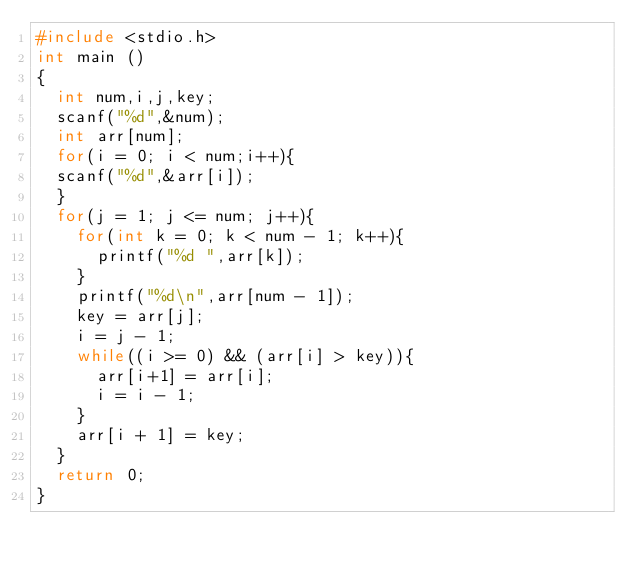Convert code to text. <code><loc_0><loc_0><loc_500><loc_500><_C_>#include <stdio.h>
int main ()
{
  int num,i,j,key;
  scanf("%d",&num);
  int arr[num];
  for(i = 0; i < num;i++){
  scanf("%d",&arr[i]);
  }
  for(j = 1; j <= num; j++){
    for(int k = 0; k < num - 1; k++){
      printf("%d ",arr[k]);
    }
    printf("%d\n",arr[num - 1]);
    key = arr[j];
    i = j - 1;
    while((i >= 0) && (arr[i] > key)){
      arr[i+1] = arr[i];
      i = i - 1;
    }
    arr[i + 1] = key;
  }
  return 0;
}


</code> 